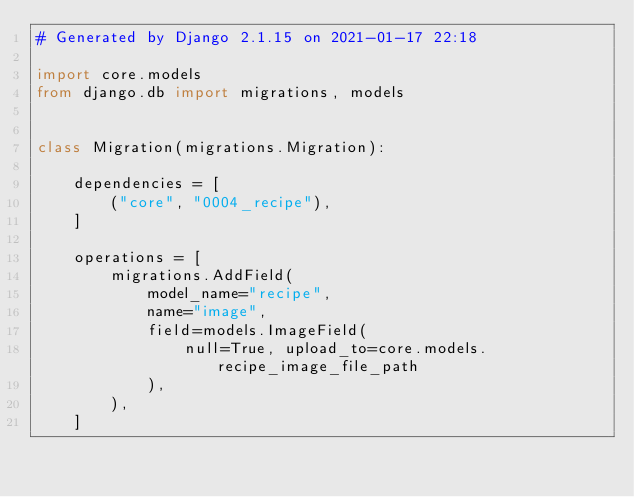Convert code to text. <code><loc_0><loc_0><loc_500><loc_500><_Python_># Generated by Django 2.1.15 on 2021-01-17 22:18

import core.models
from django.db import migrations, models


class Migration(migrations.Migration):

    dependencies = [
        ("core", "0004_recipe"),
    ]

    operations = [
        migrations.AddField(
            model_name="recipe",
            name="image",
            field=models.ImageField(
                null=True, upload_to=core.models.recipe_image_file_path
            ),
        ),
    ]
</code> 